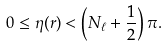Convert formula to latex. <formula><loc_0><loc_0><loc_500><loc_500>0 \leq \eta ( r ) < \left ( N _ { \ell } + \frac { 1 } { 2 } \right ) \pi .</formula> 